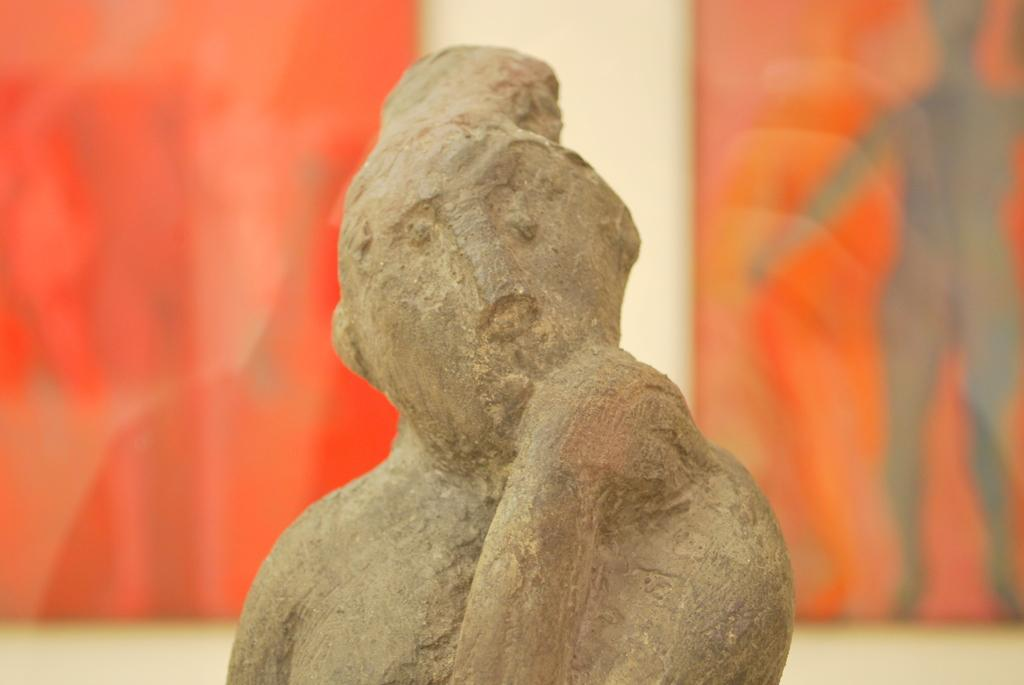What is the main subject of the image? There is a sculpture in the image. Can you describe any other elements in the image? Yes, there are boards attached to the wall in the image. What direction is the mint growing in the image? There is no mint present in the image. Is there a camp visible in the image? No, there is no camp visible in the image. 